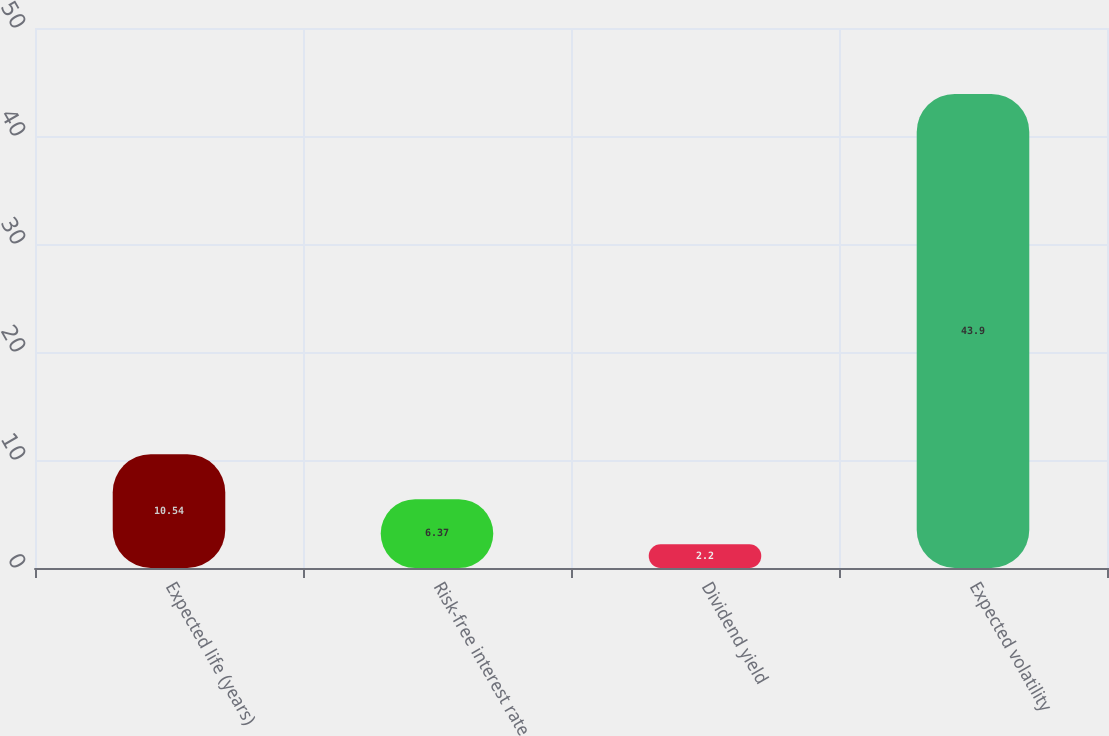Convert chart to OTSL. <chart><loc_0><loc_0><loc_500><loc_500><bar_chart><fcel>Expected life (years)<fcel>Risk-free interest rate<fcel>Dividend yield<fcel>Expected volatility<nl><fcel>10.54<fcel>6.37<fcel>2.2<fcel>43.9<nl></chart> 